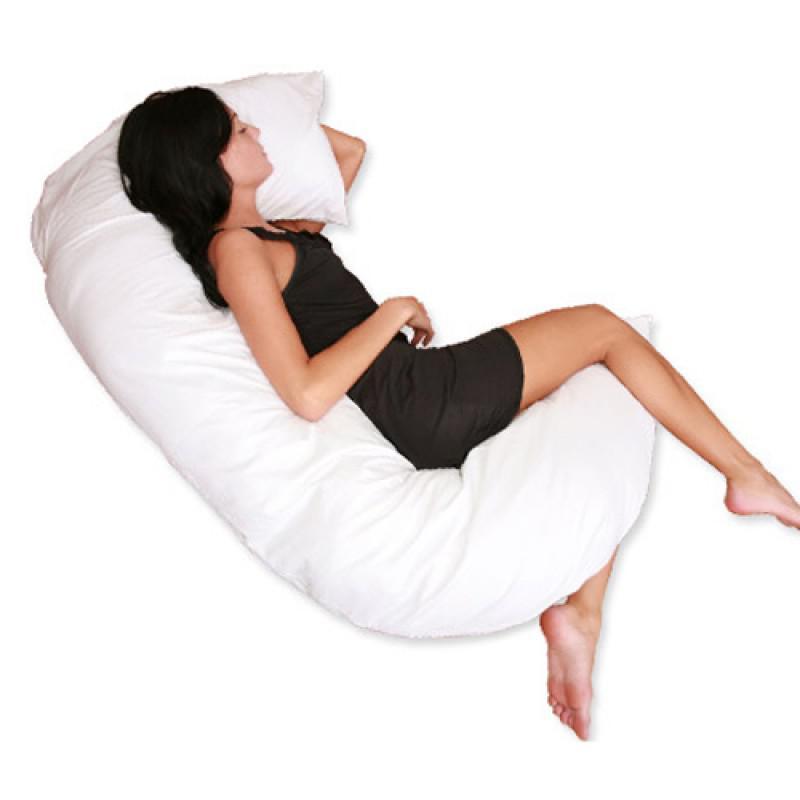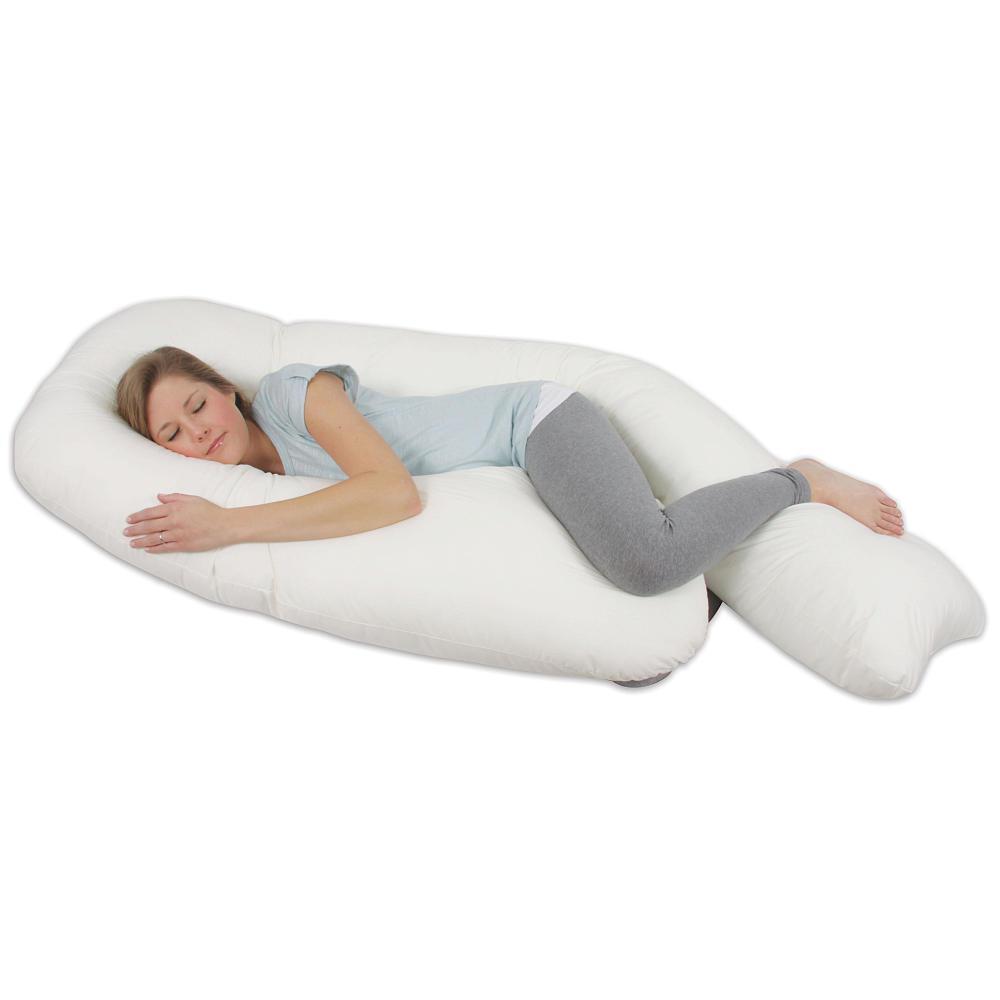The first image is the image on the left, the second image is the image on the right. For the images shown, is this caption "A pair of pillows are printed with spoon shapes below lettering." true? Answer yes or no. No. The first image is the image on the left, the second image is the image on the right. Examine the images to the left and right. Is the description "All big spoons are to the left." accurate? Answer yes or no. No. 